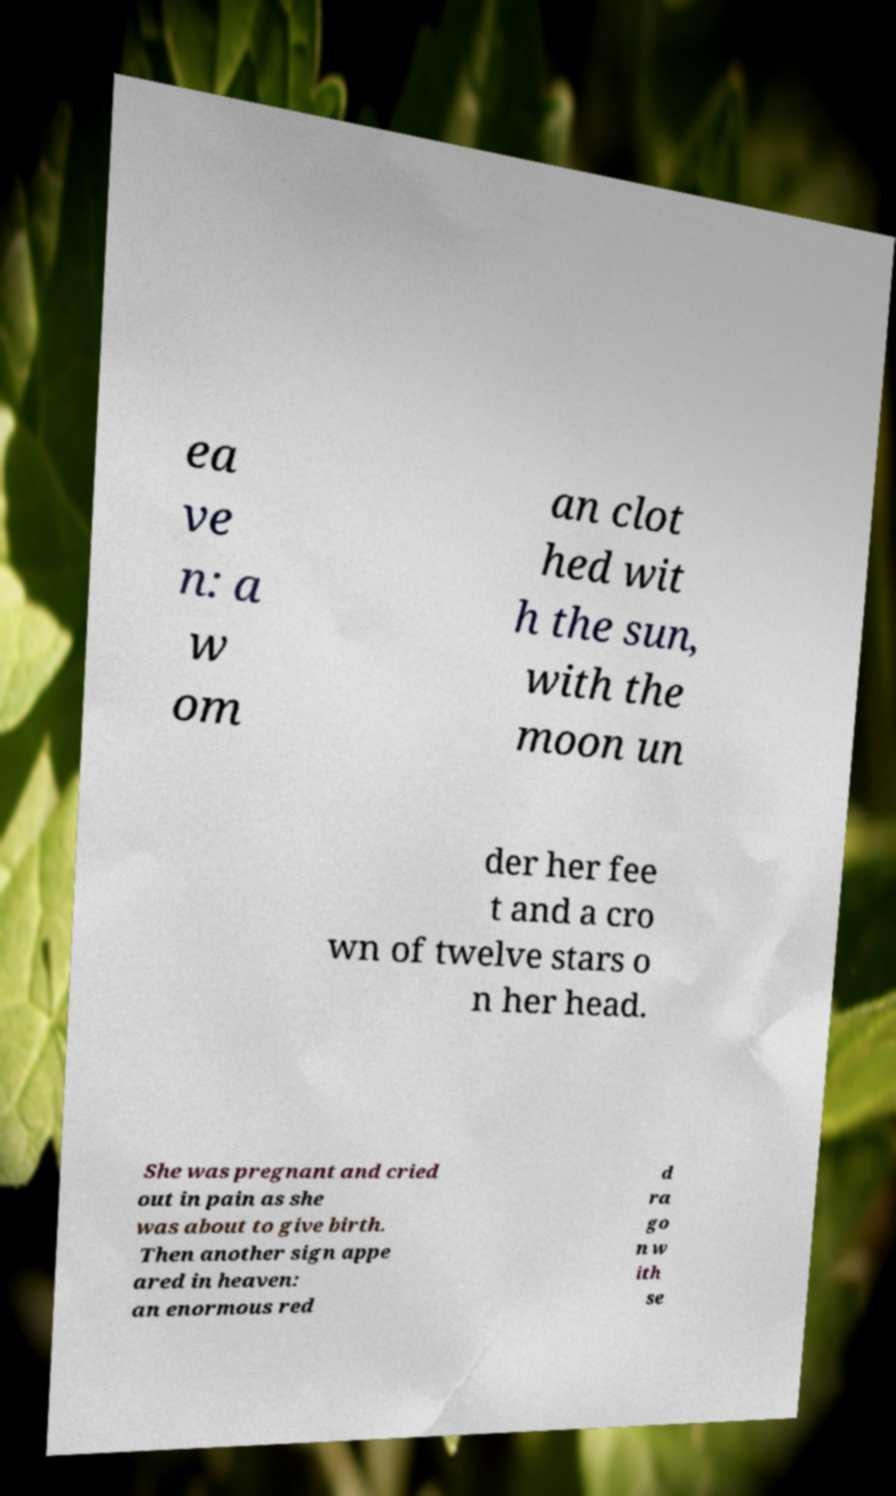Could you extract and type out the text from this image? ea ve n: a w om an clot hed wit h the sun, with the moon un der her fee t and a cro wn of twelve stars o n her head. She was pregnant and cried out in pain as she was about to give birth. Then another sign appe ared in heaven: an enormous red d ra go n w ith se 